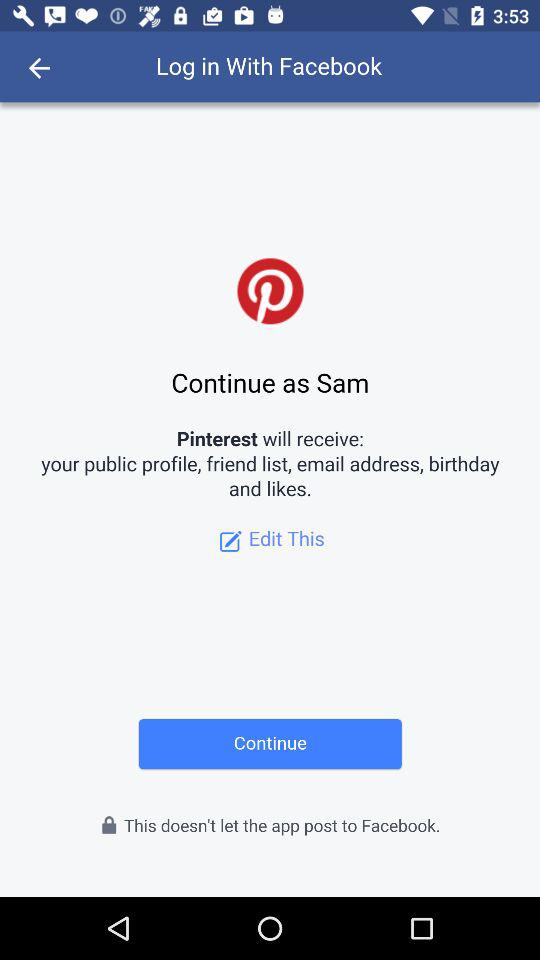Which information will "Pinterest" receive? "Pinterest" will receive your public profile, friend list, email address, birthday and likes. 